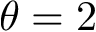<formula> <loc_0><loc_0><loc_500><loc_500>\theta = 2</formula> 